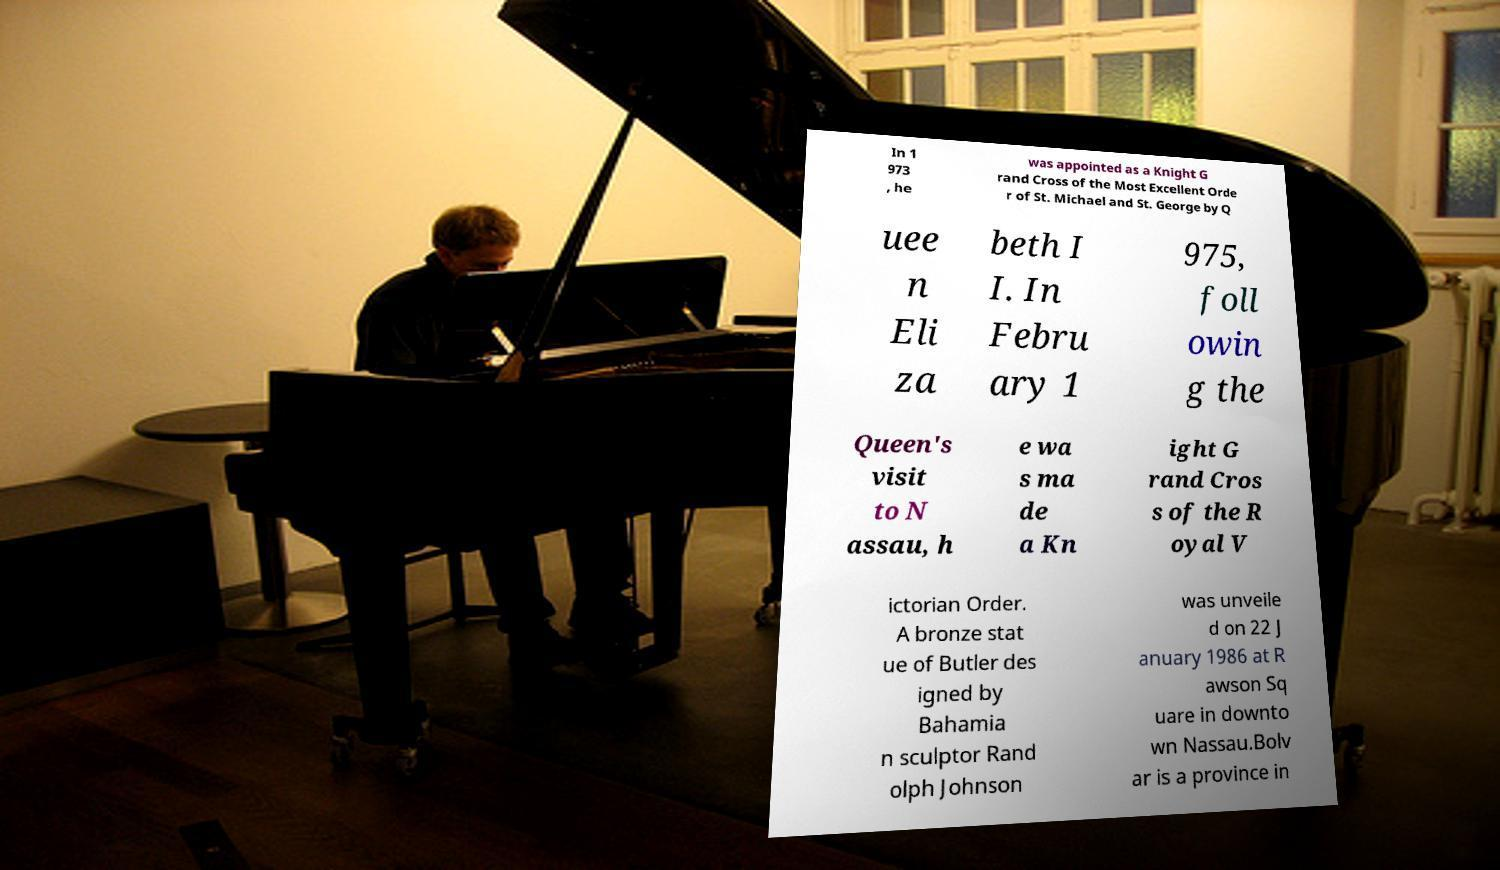What messages or text are displayed in this image? I need them in a readable, typed format. In 1 973 , he was appointed as a Knight G rand Cross of the Most Excellent Orde r of St. Michael and St. George by Q uee n Eli za beth I I. In Febru ary 1 975, foll owin g the Queen's visit to N assau, h e wa s ma de a Kn ight G rand Cros s of the R oyal V ictorian Order. A bronze stat ue of Butler des igned by Bahamia n sculptor Rand olph Johnson was unveile d on 22 J anuary 1986 at R awson Sq uare in downto wn Nassau.Bolv ar is a province in 